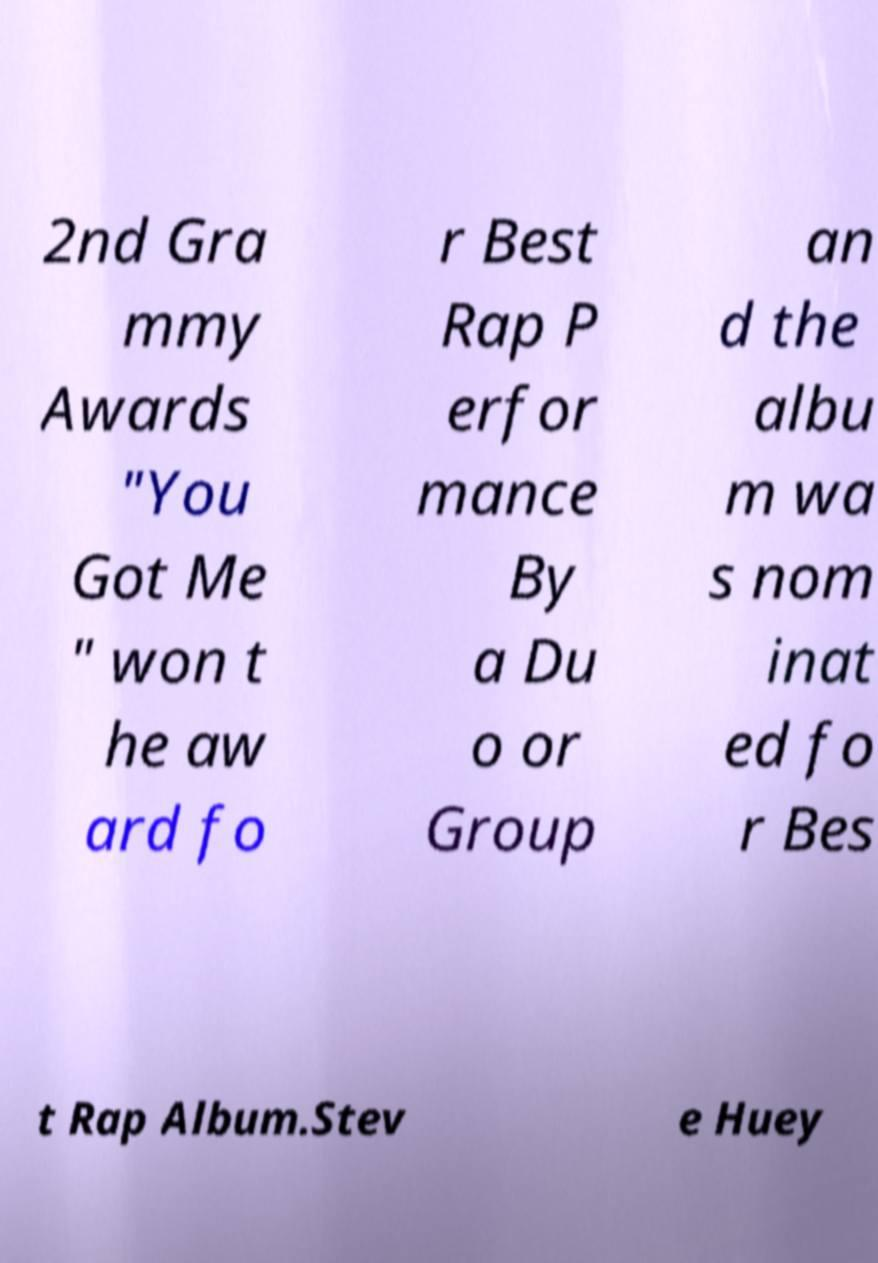Please identify and transcribe the text found in this image. 2nd Gra mmy Awards "You Got Me " won t he aw ard fo r Best Rap P erfor mance By a Du o or Group an d the albu m wa s nom inat ed fo r Bes t Rap Album.Stev e Huey 